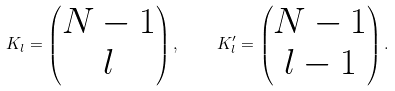<formula> <loc_0><loc_0><loc_500><loc_500>K _ { l } = \left ( \begin{matrix} N - 1 \\ l \\ \end{matrix} \right ) , \quad K _ { l } ^ { \prime } = \left ( \begin{matrix} N - 1 \\ l - 1 \\ \end{matrix} \right ) .</formula> 